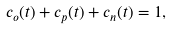Convert formula to latex. <formula><loc_0><loc_0><loc_500><loc_500>c _ { o } ( t ) + c _ { p } ( t ) + c _ { n } ( t ) = 1 ,</formula> 